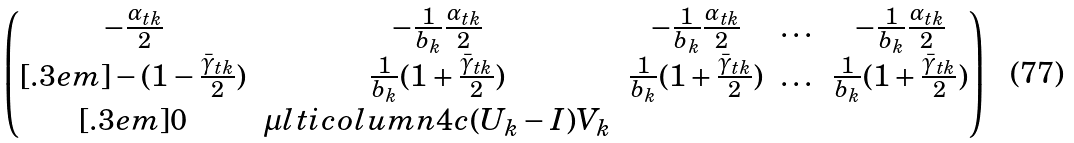Convert formula to latex. <formula><loc_0><loc_0><loc_500><loc_500>\begin{pmatrix} - \frac { \alpha _ { t k } } { 2 } & - \frac { 1 } { b _ { k } } \frac { \alpha _ { t k } } { 2 } & - \frac { 1 } { b _ { k } } \frac { \alpha _ { t k } } { 2 } & \dots & - \frac { 1 } { b _ { k } } \frac { \alpha _ { t k } } { 2 } \\ [ . 3 e m ] - ( 1 - \frac { \bar { \gamma } _ { t k } } { 2 } ) & \frac { 1 } { b _ { k } } ( 1 + \frac { \bar { \gamma } _ { t k } } { 2 } ) & \frac { 1 } { b _ { k } } ( 1 + \frac { \bar { \gamma } _ { t k } } { 2 } ) & \dots & \frac { 1 } { b _ { k } } ( 1 + \frac { \bar { \gamma } _ { t k } } { 2 } ) \\ [ . 3 e m ] 0 & \mu l t i c o l u m n { 4 } { c } { ( U _ { k } - I ) V _ { k } } \end{pmatrix}</formula> 